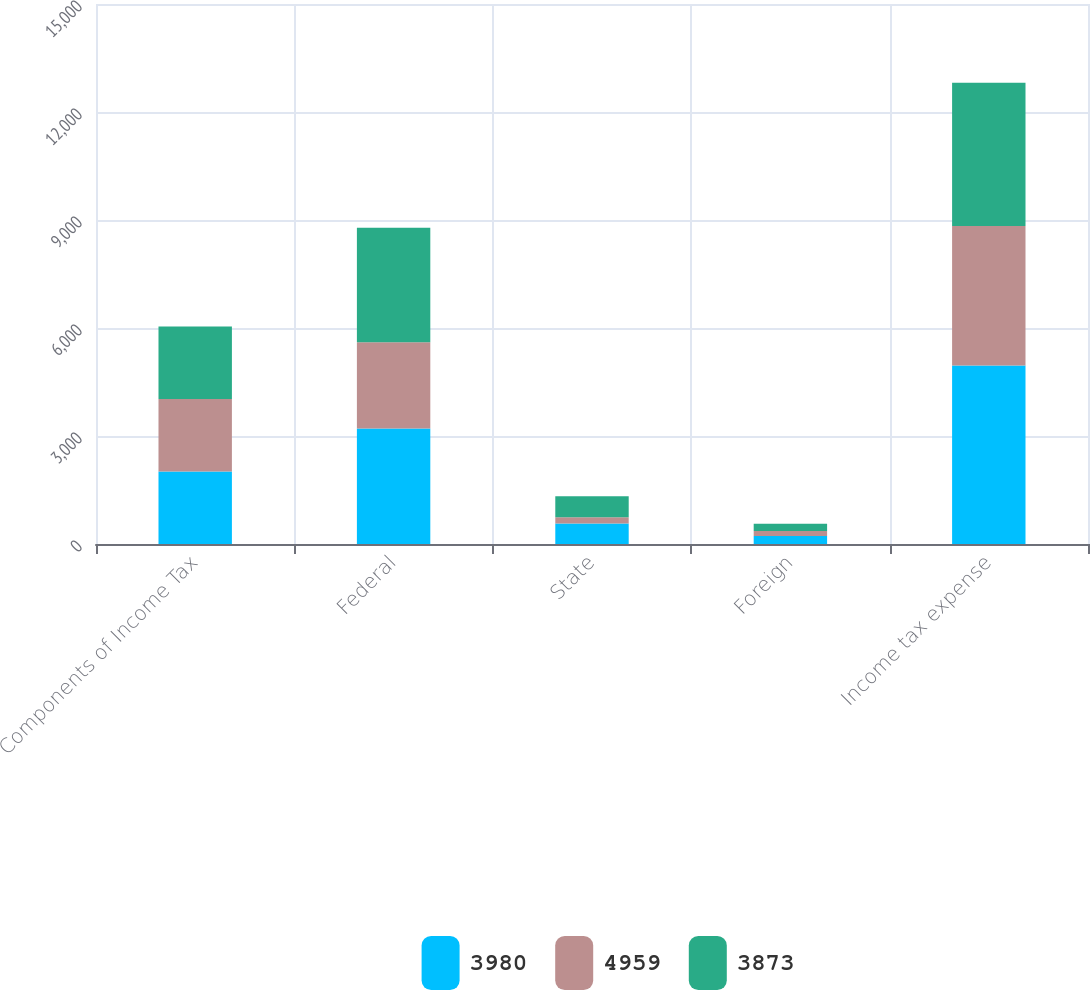Convert chart to OTSL. <chart><loc_0><loc_0><loc_500><loc_500><stacked_bar_chart><ecel><fcel>Components of Income Tax<fcel>Federal<fcel>State<fcel>Foreign<fcel>Income tax expense<nl><fcel>3980<fcel>2015<fcel>3210<fcel>570<fcel>221<fcel>4959<nl><fcel>4959<fcel>2014<fcel>2392<fcel>174<fcel>142<fcel>3873<nl><fcel>3873<fcel>2013<fcel>3183<fcel>581<fcel>200<fcel>3980<nl></chart> 